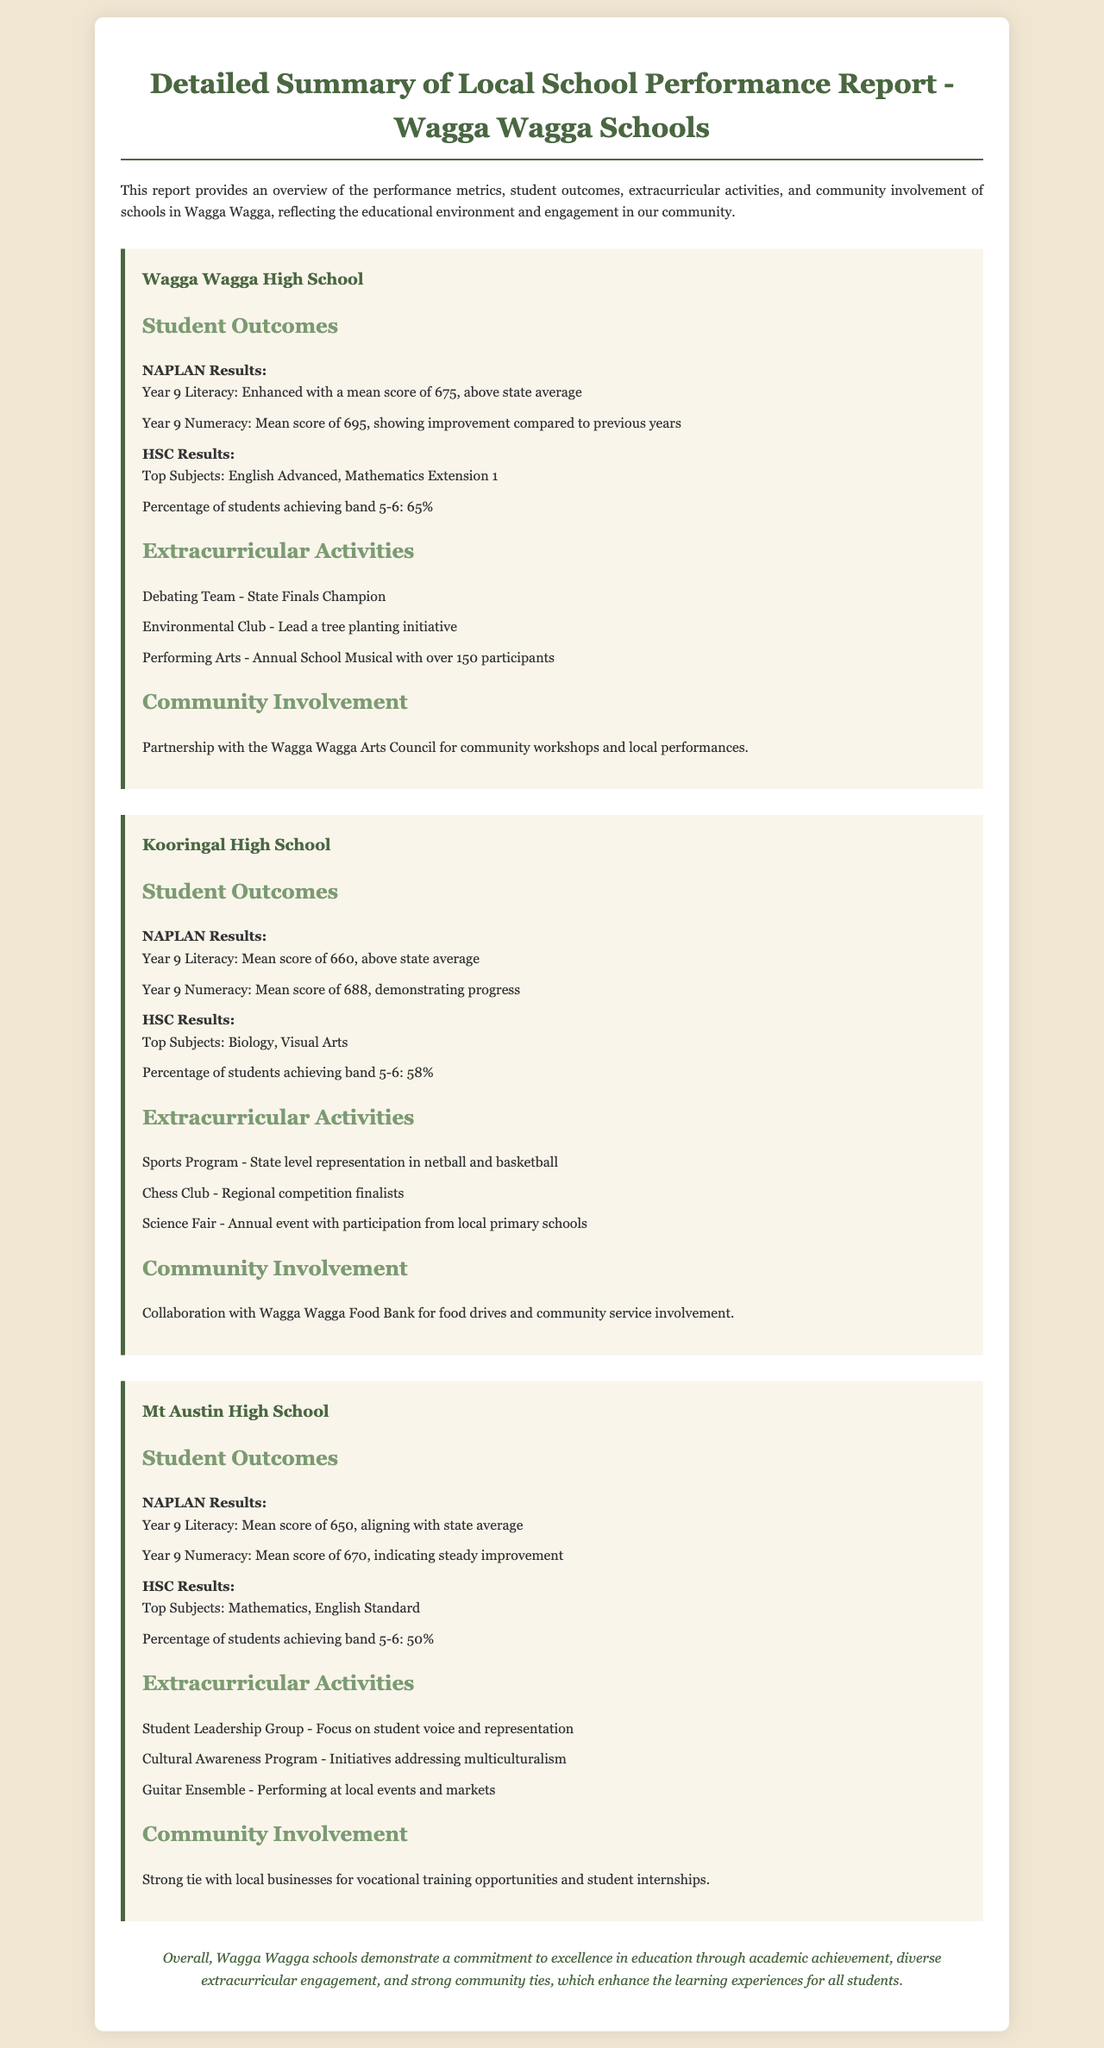What is the mean score for Year 9 Literacy at Wagga Wagga High School? The mean score for Year 9 Literacy at Wagga Wagga High School is stated as 675, which is above the state average.
Answer: 675 What percentage of Kooringal High School students achieved band 5-6 in HSC results? The document reveals that 58% of Kooringal High School students achieved band 5-6 in HSC results.
Answer: 58% Which school has a Debating Team that is a state finals champion? The document indicates that Wagga Wagga High School's Debating Team is a state finals champion.
Answer: Wagga Wagga High School What type of community service is Kooringal High School involved in? It collaborates with the Wagga Wagga Food Bank for food drives and community service involvement, indicating its type of community service.
Answer: Food drives How many students participated in the annual school musical at Wagga Wagga High School? The document mentions that over 150 participants were involved in the annual school musical at Wagga Wagga High School.
Answer: Over 150 participants Which two subjects are the top for Mt Austin High School in HSC results? The top subjects for Mt Austin High School in HSC results are Mathematics and English Standard, as stated in the document.
Answer: Mathematics, English Standard What is the mean score for Year 9 Numeracy at Mt Austin High School? The document details that the mean score for Year 9 Numeracy at Mt Austin High School is 670, indicating steady improvement.
Answer: 670 What community partnership does Wagga Wagga High School have? The document describes a partnership with the Wagga Wagga Arts Council for workshops and performances, which indicates their community partnership.
Answer: Wagga Wagga Arts Council 